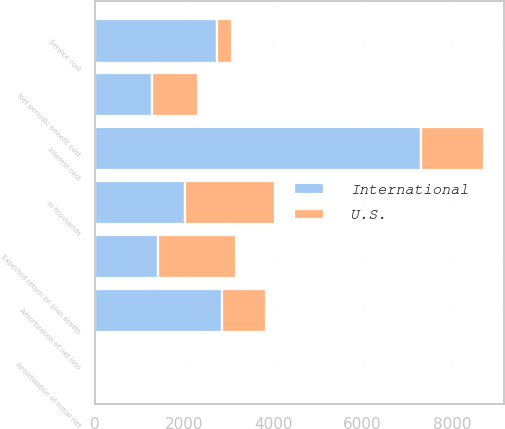Convert chart. <chart><loc_0><loc_0><loc_500><loc_500><stacked_bar_chart><ecel><fcel>In thousands<fcel>Service cost<fcel>Interest cost<fcel>Expected return on plan assets<fcel>Amortization of initial net<fcel>Amortization of net loss<fcel>Net periodic benefit cost<nl><fcel>U.S.<fcel>2017<fcel>344<fcel>1422<fcel>1731<fcel>3<fcel>989<fcel>1027<nl><fcel>International<fcel>2017<fcel>2740<fcel>7310<fcel>1422<fcel>27<fcel>2846<fcel>1279<nl></chart> 